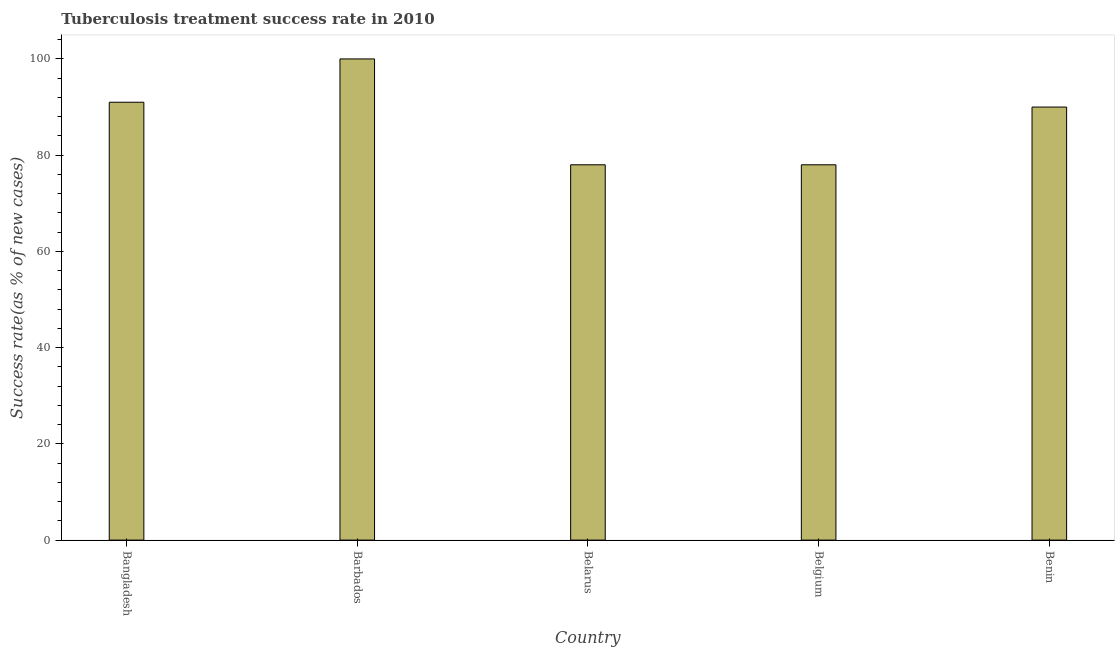What is the title of the graph?
Provide a succinct answer. Tuberculosis treatment success rate in 2010. What is the label or title of the Y-axis?
Your answer should be very brief. Success rate(as % of new cases). In which country was the tuberculosis treatment success rate maximum?
Your answer should be compact. Barbados. In which country was the tuberculosis treatment success rate minimum?
Keep it short and to the point. Belarus. What is the sum of the tuberculosis treatment success rate?
Offer a terse response. 437. What is the median tuberculosis treatment success rate?
Keep it short and to the point. 90. What is the ratio of the tuberculosis treatment success rate in Barbados to that in Belgium?
Make the answer very short. 1.28. Is the tuberculosis treatment success rate in Belarus less than that in Benin?
Your answer should be very brief. Yes. Is the difference between the tuberculosis treatment success rate in Bangladesh and Barbados greater than the difference between any two countries?
Provide a succinct answer. No. What is the difference between the highest and the second highest tuberculosis treatment success rate?
Give a very brief answer. 9. Is the sum of the tuberculosis treatment success rate in Barbados and Belarus greater than the maximum tuberculosis treatment success rate across all countries?
Keep it short and to the point. Yes. How many countries are there in the graph?
Ensure brevity in your answer.  5. What is the Success rate(as % of new cases) of Bangladesh?
Provide a succinct answer. 91. What is the Success rate(as % of new cases) of Barbados?
Offer a very short reply. 100. What is the Success rate(as % of new cases) of Belarus?
Provide a succinct answer. 78. What is the Success rate(as % of new cases) of Benin?
Keep it short and to the point. 90. What is the difference between the Success rate(as % of new cases) in Bangladesh and Barbados?
Your response must be concise. -9. What is the difference between the Success rate(as % of new cases) in Bangladesh and Benin?
Your response must be concise. 1. What is the difference between the Success rate(as % of new cases) in Barbados and Benin?
Keep it short and to the point. 10. What is the ratio of the Success rate(as % of new cases) in Bangladesh to that in Barbados?
Ensure brevity in your answer.  0.91. What is the ratio of the Success rate(as % of new cases) in Bangladesh to that in Belarus?
Offer a very short reply. 1.17. What is the ratio of the Success rate(as % of new cases) in Bangladesh to that in Belgium?
Provide a short and direct response. 1.17. What is the ratio of the Success rate(as % of new cases) in Barbados to that in Belarus?
Provide a short and direct response. 1.28. What is the ratio of the Success rate(as % of new cases) in Barbados to that in Belgium?
Ensure brevity in your answer.  1.28. What is the ratio of the Success rate(as % of new cases) in Barbados to that in Benin?
Ensure brevity in your answer.  1.11. What is the ratio of the Success rate(as % of new cases) in Belarus to that in Belgium?
Offer a terse response. 1. What is the ratio of the Success rate(as % of new cases) in Belarus to that in Benin?
Keep it short and to the point. 0.87. What is the ratio of the Success rate(as % of new cases) in Belgium to that in Benin?
Your response must be concise. 0.87. 